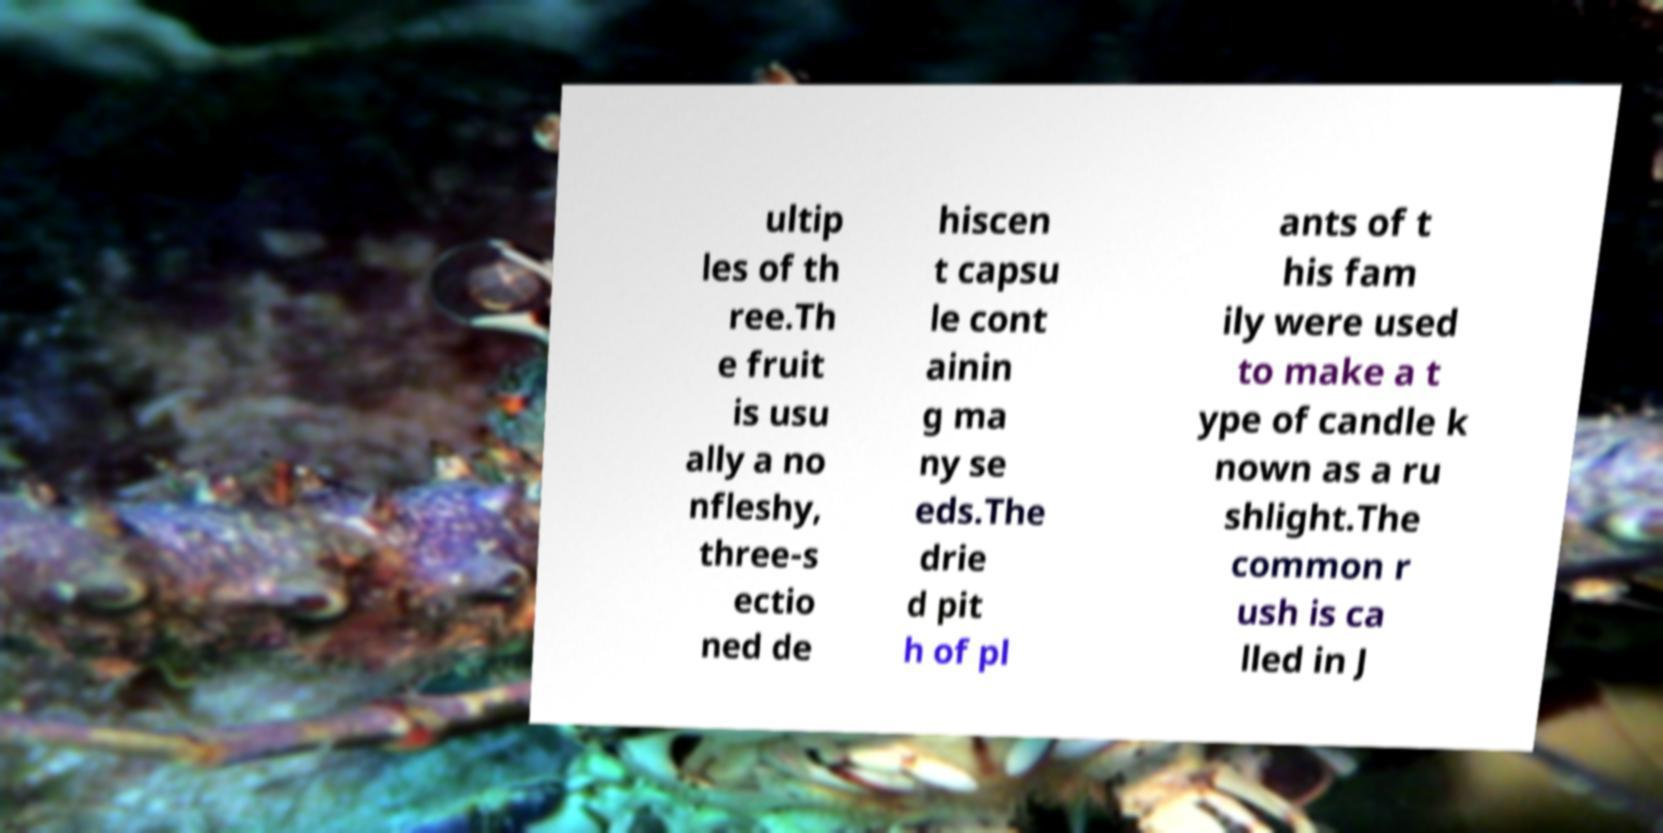I need the written content from this picture converted into text. Can you do that? ultip les of th ree.Th e fruit is usu ally a no nfleshy, three-s ectio ned de hiscen t capsu le cont ainin g ma ny se eds.The drie d pit h of pl ants of t his fam ily were used to make a t ype of candle k nown as a ru shlight.The common r ush is ca lled in J 